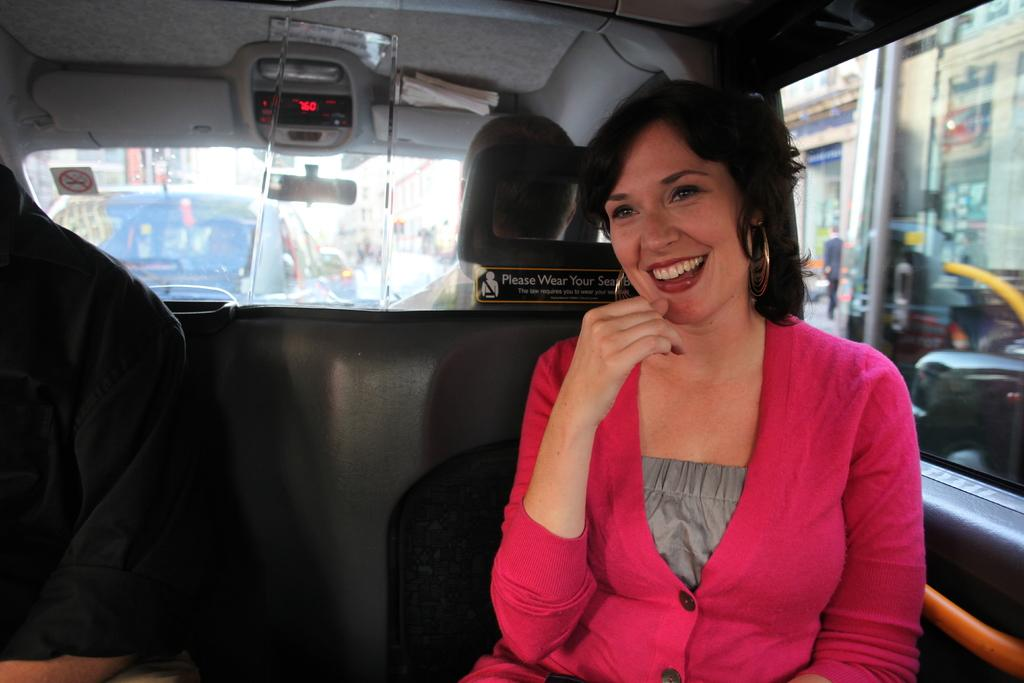Who is present in the image? There is a woman in the image. What is the woman doing in the image? The woman is sitting in a car and laughing. What else can be seen in the image besides the woman? There are vehicles and buildings visible in the image. Is there anyone else in the car with the woman? Yes, there is a person sitting near the woman in the car. What type of vegetable is the woman holding in the image? There is no vegetable present in the image; the woman is sitting in a car and laughing. Can you tell me how many zephyrs are visible in the image? There is no mention of zephyrs in the image; it features a woman sitting in a car and laughing, along with other vehicles and buildings. 